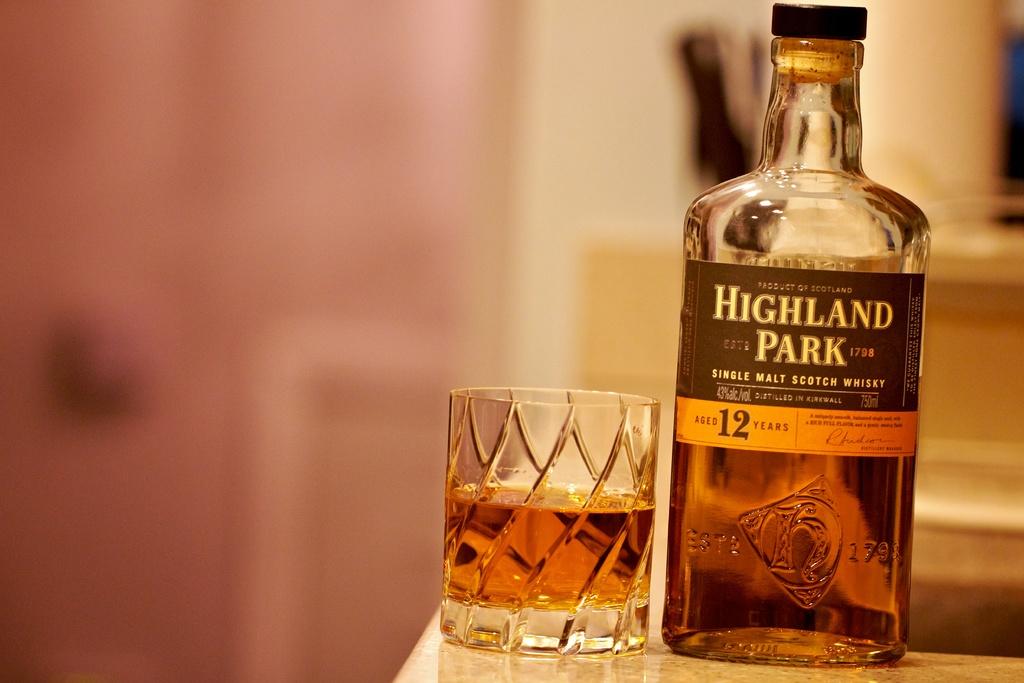What is the name of the whiskey?
Your answer should be compact. Highland park. Where is this whiskey made?
Offer a terse response. Highland park. 